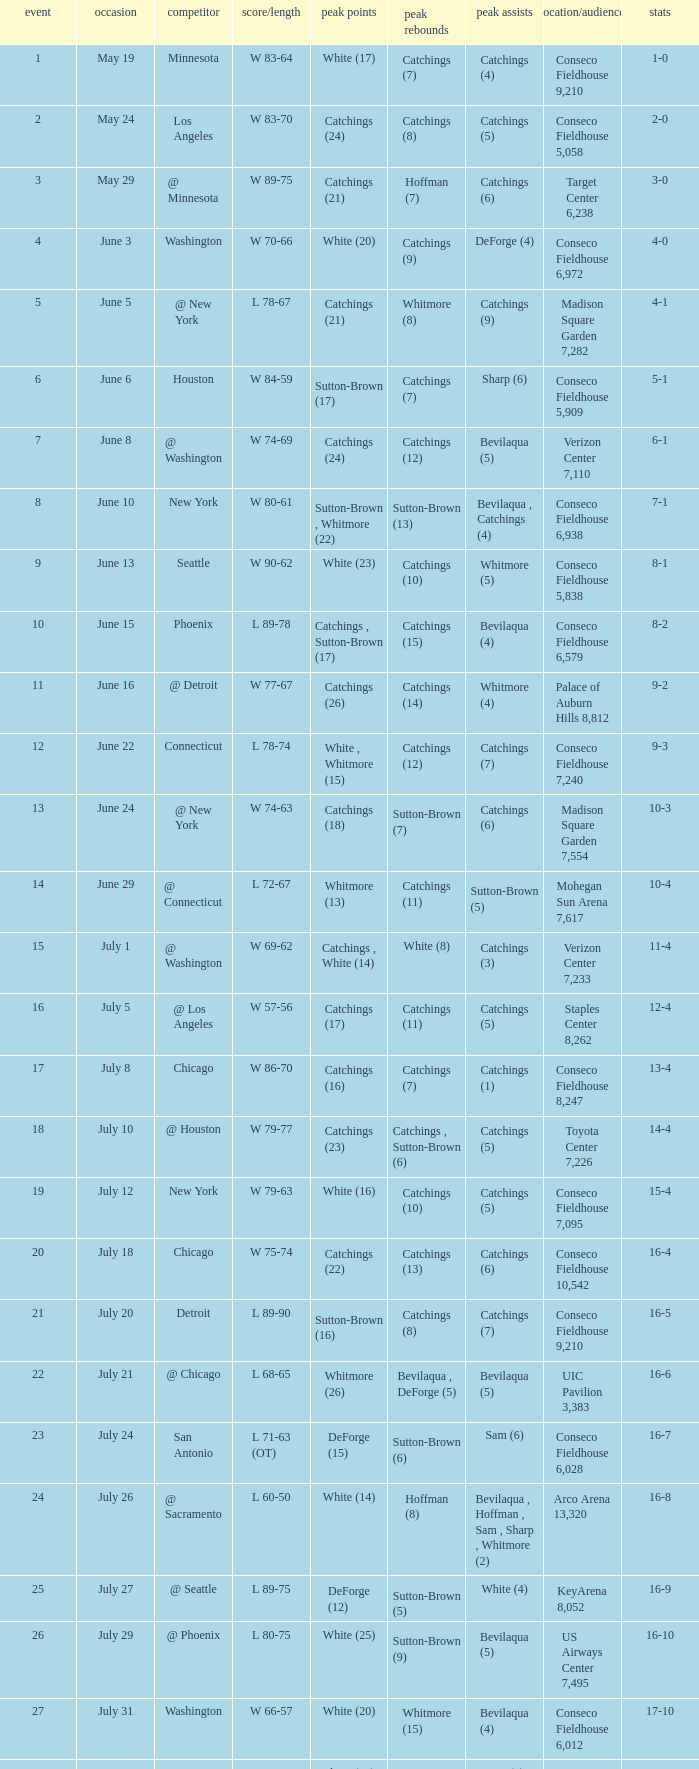Name the total number of opponent of record 9-2 1.0. 